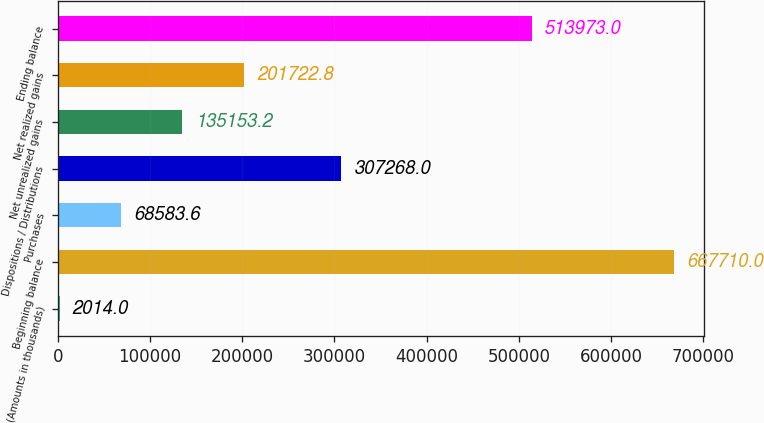Convert chart to OTSL. <chart><loc_0><loc_0><loc_500><loc_500><bar_chart><fcel>(Amounts in thousands)<fcel>Beginning balance<fcel>Purchases<fcel>Dispositions / Distributions<fcel>Net unrealized gains<fcel>Net realized gains<fcel>Ending balance<nl><fcel>2014<fcel>667710<fcel>68583.6<fcel>307268<fcel>135153<fcel>201723<fcel>513973<nl></chart> 